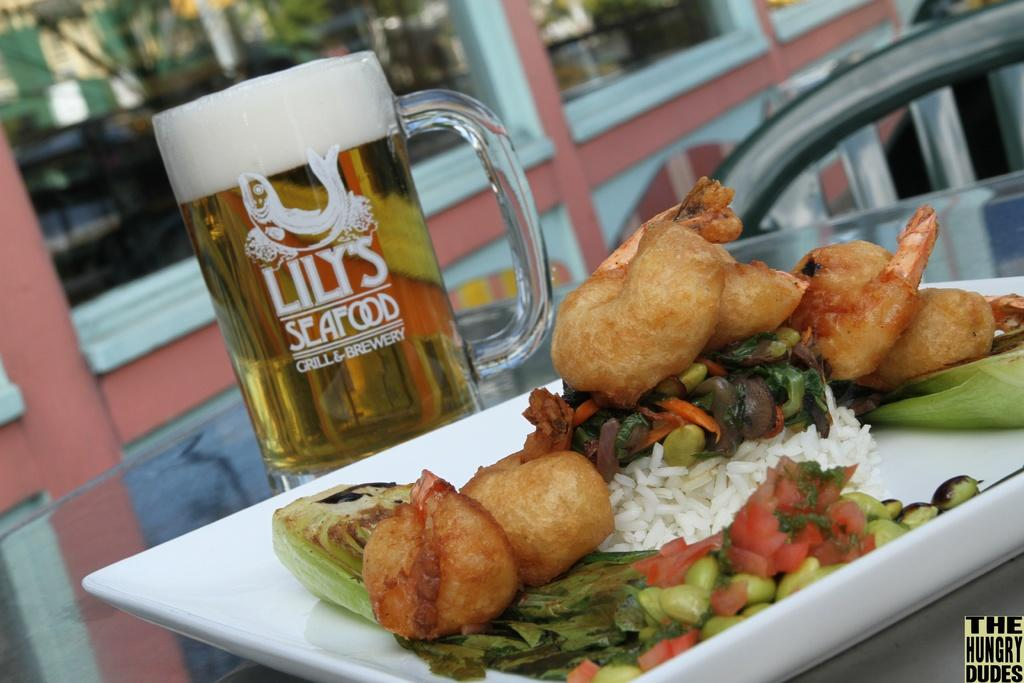What is on the plate that is visible in the image? There is food in a plate in the image. What else can be seen on the table in the image? There is a beer glass on the table in the image. What is the name of the sister who is not present in the image? There is no mention of a sister in the image or the provided facts, so it is not possible to determine her name. 